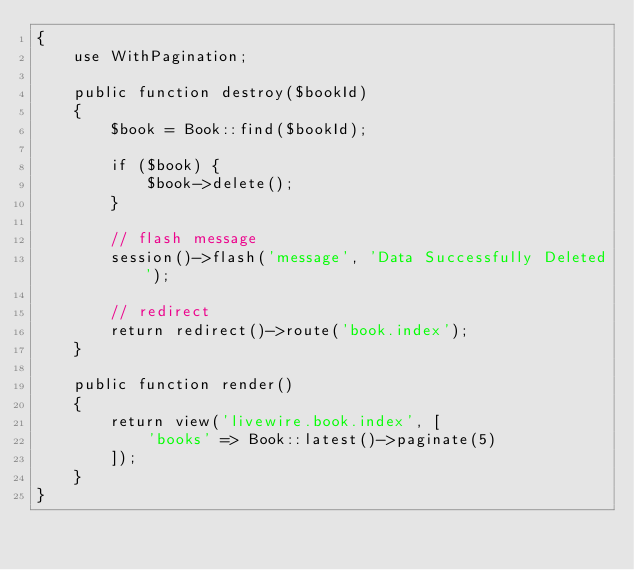Convert code to text. <code><loc_0><loc_0><loc_500><loc_500><_PHP_>{
    use WithPagination;

    public function destroy($bookId)
    {
        $book = Book::find($bookId);

        if ($book) {
            $book->delete();
        }

        // flash message
        session()->flash('message', 'Data Successfully Deleted');

        // redirect
        return redirect()->route('book.index');
    }

    public function render()
    {
        return view('livewire.book.index', [
            'books' => Book::latest()->paginate(5)
        ]);
    }
}
</code> 